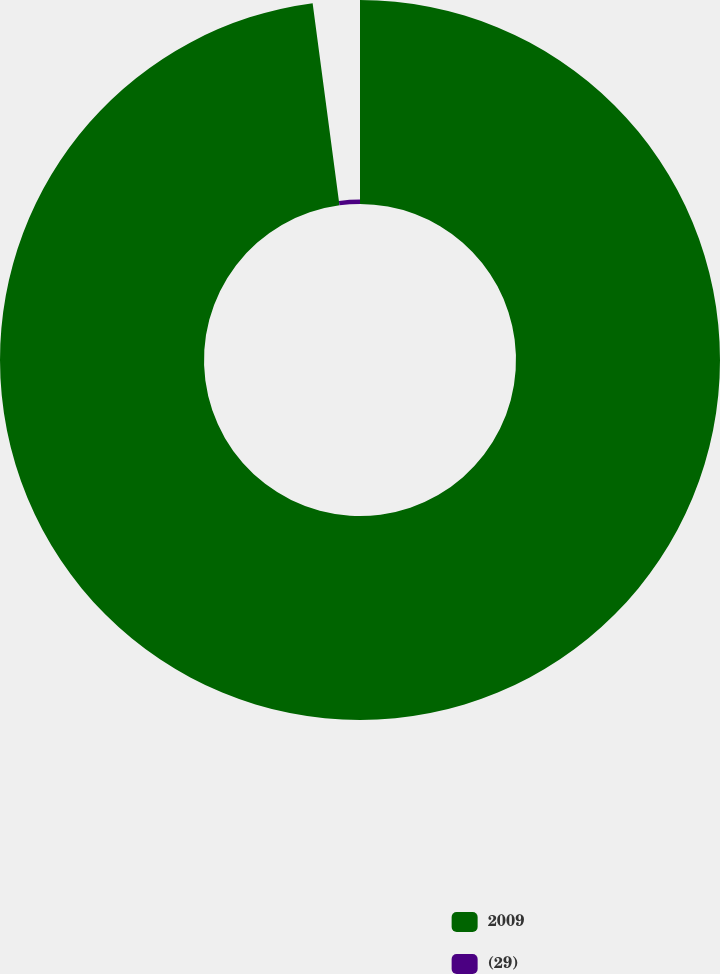Convert chart. <chart><loc_0><loc_0><loc_500><loc_500><pie_chart><fcel>2009<fcel>(29)<nl><fcel>97.9%<fcel>2.1%<nl></chart> 